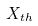Convert formula to latex. <formula><loc_0><loc_0><loc_500><loc_500>X _ { t h }</formula> 